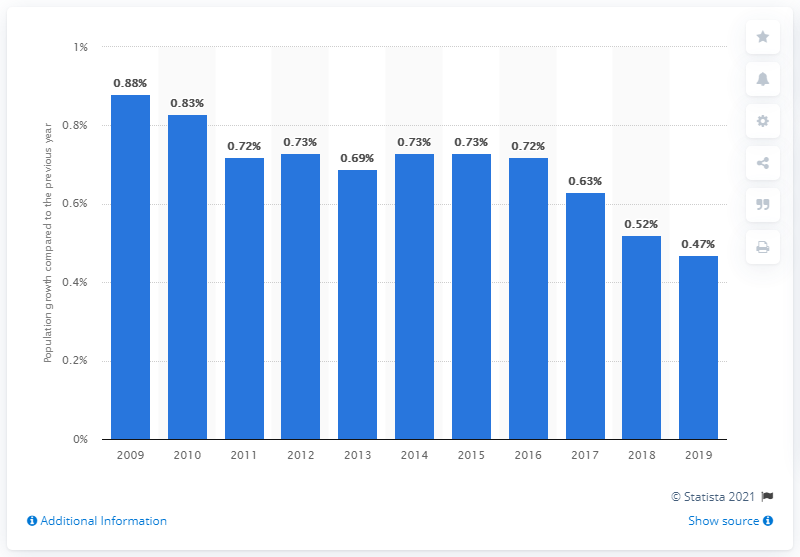Point out several critical features in this image. The population of the United States increased by 0.47% in 2019 compared to the previous year. 